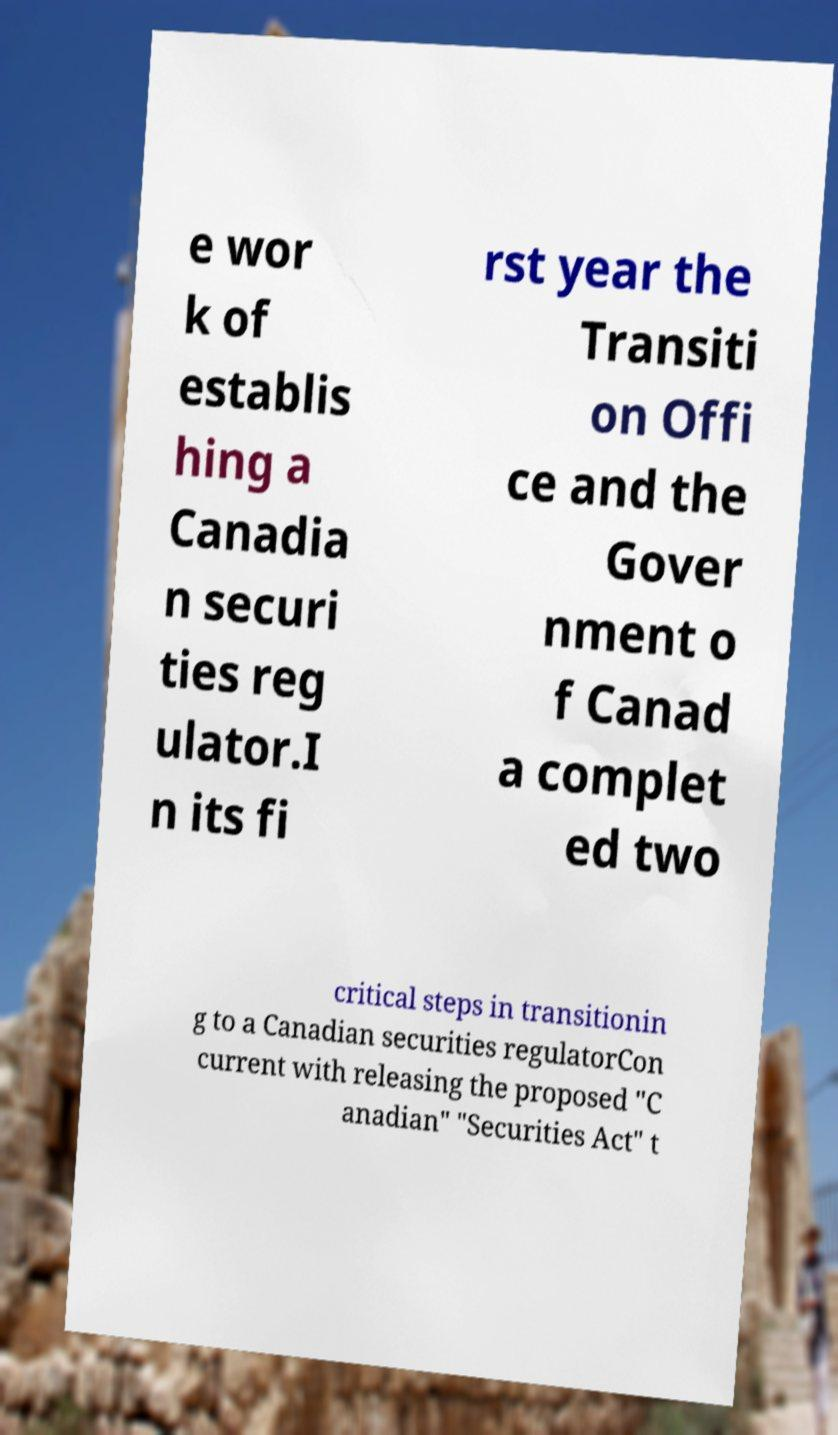What messages or text are displayed in this image? I need them in a readable, typed format. e wor k of establis hing a Canadia n securi ties reg ulator.I n its fi rst year the Transiti on Offi ce and the Gover nment o f Canad a complet ed two critical steps in transitionin g to a Canadian securities regulatorCon current with releasing the proposed "C anadian" "Securities Act" t 